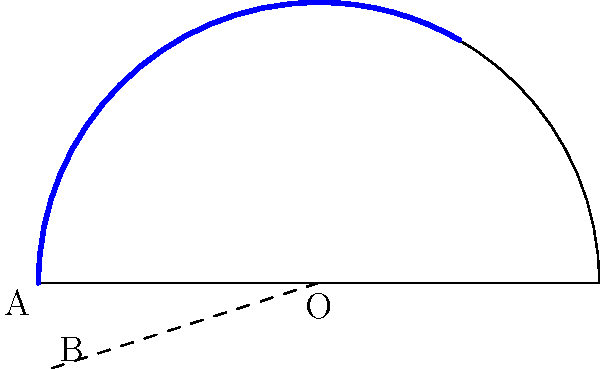You're designing a semi-circular bar counter for a new ski resort restaurant. The radius of the counter is 3 meters, and you want to add a special lighting feature along a portion of the counter. If this portion spans an angle of 60° at the center, what is the length of the arc where the lighting will be installed? To find the length of the arc, we'll use the formula for arc length:

Arc length = $\frac{\theta}{360°} \cdot 2\pi r$

Where:
$\theta$ is the central angle in degrees
$r$ is the radius of the circle

Given:
- Radius (r) = 3 meters
- Central angle ($\theta$) = 60°

Step 1: Substitute the values into the formula.
Arc length = $\frac{60°}{360°} \cdot 2\pi \cdot 3$

Step 2: Simplify the fraction.
Arc length = $\frac{1}{6} \cdot 2\pi \cdot 3$

Step 3: Multiply the terms.
Arc length = $\pi$

Therefore, the length of the arc where the lighting will be installed is $\pi$ meters.
Answer: $\pi$ meters 